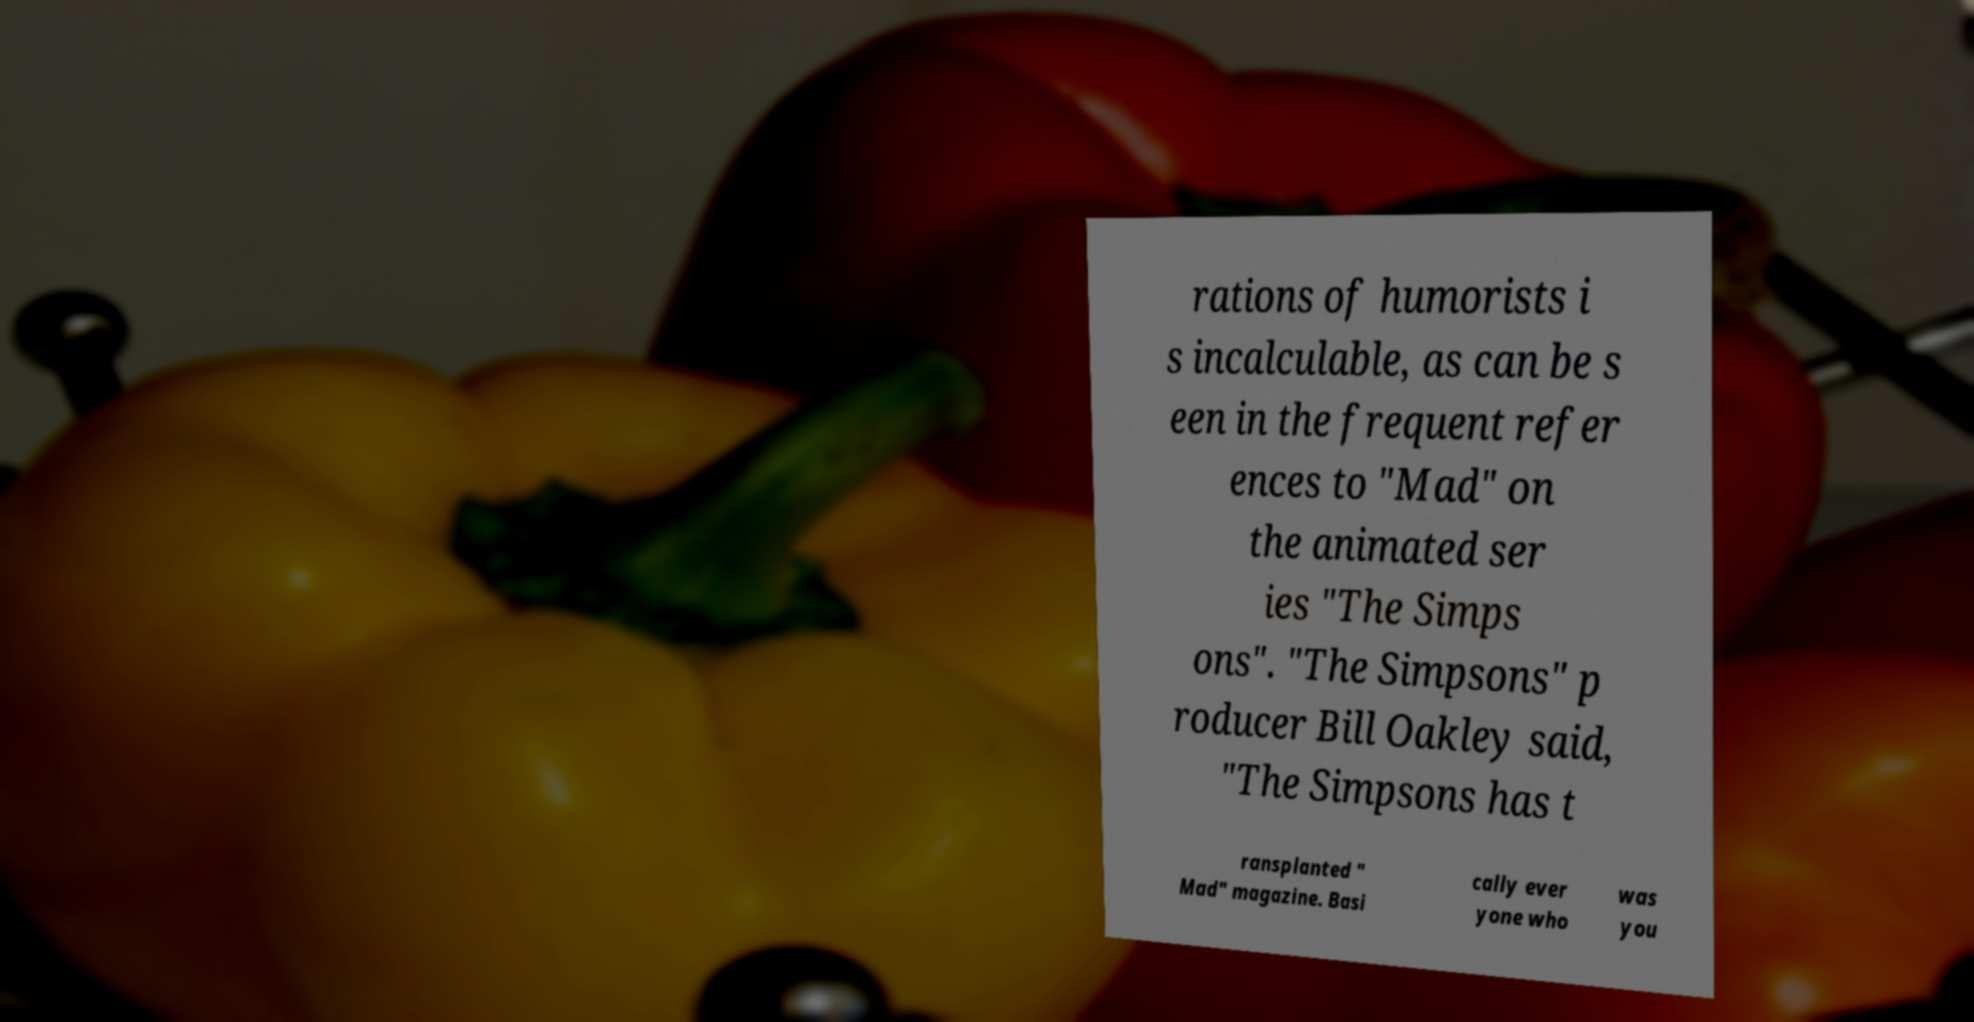Could you extract and type out the text from this image? rations of humorists i s incalculable, as can be s een in the frequent refer ences to "Mad" on the animated ser ies "The Simps ons". "The Simpsons" p roducer Bill Oakley said, "The Simpsons has t ransplanted " Mad" magazine. Basi cally ever yone who was you 